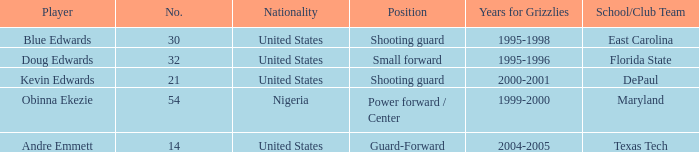In which place did kevin edwards participate for? Shooting guard. 